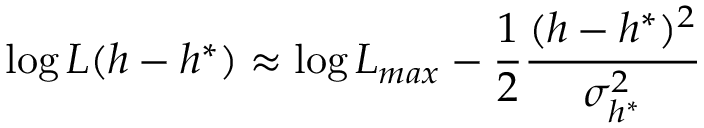<formula> <loc_0><loc_0><loc_500><loc_500>\log L ( h - h ^ { * } ) \approx \log L _ { \max } - \frac { 1 } { 2 } \frac { ( h - h ^ { * } ) ^ { 2 } } { \sigma _ { h ^ { * } } ^ { 2 } }</formula> 